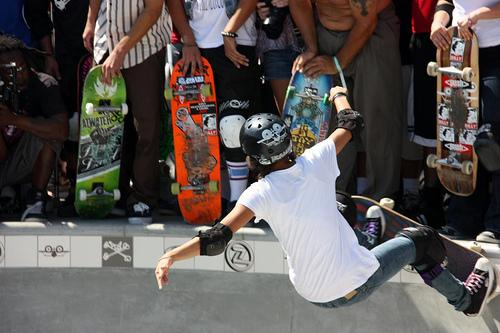Where did OG skateboarders develop this style of boarding?

Choices:
A) underpasses
B) skateparks
C) canals
D) swimming pools swimming pools 